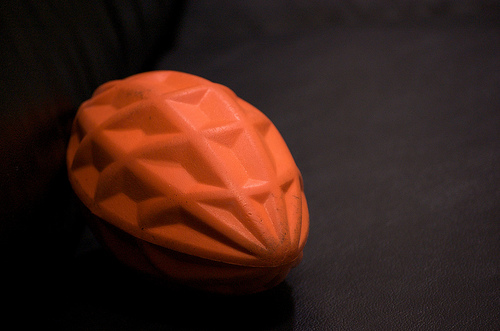<image>
Can you confirm if the toy is on the surface? Yes. Looking at the image, I can see the toy is positioned on top of the surface, with the surface providing support. 